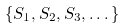<formula> <loc_0><loc_0><loc_500><loc_500>\{ S _ { 1 } , S _ { 2 } , S _ { 3 } , \dots \}</formula> 